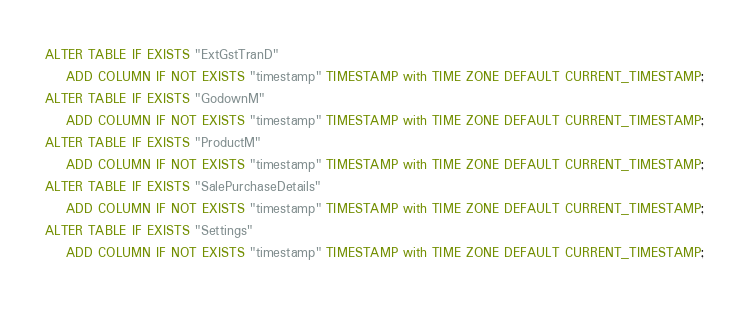<code> <loc_0><loc_0><loc_500><loc_500><_SQL_>ALTER TABLE IF EXISTS "ExtGstTranD"
	ADD COLUMN IF NOT EXISTS "timestamp" TIMESTAMP with TIME ZONE DEFAULT CURRENT_TIMESTAMP;
ALTER TABLE IF EXISTS "GodownM"
	ADD COLUMN IF NOT EXISTS "timestamp" TIMESTAMP with TIME ZONE DEFAULT CURRENT_TIMESTAMP;
ALTER TABLE IF EXISTS "ProductM"
	ADD COLUMN IF NOT EXISTS "timestamp" TIMESTAMP with TIME ZONE DEFAULT CURRENT_TIMESTAMP;
ALTER TABLE IF EXISTS "SalePurchaseDetails"
	ADD COLUMN IF NOT EXISTS "timestamp" TIMESTAMP with TIME ZONE DEFAULT CURRENT_TIMESTAMP;
ALTER TABLE IF EXISTS "Settings"
	ADD COLUMN IF NOT EXISTS "timestamp" TIMESTAMP with TIME ZONE DEFAULT CURRENT_TIMESTAMP;</code> 